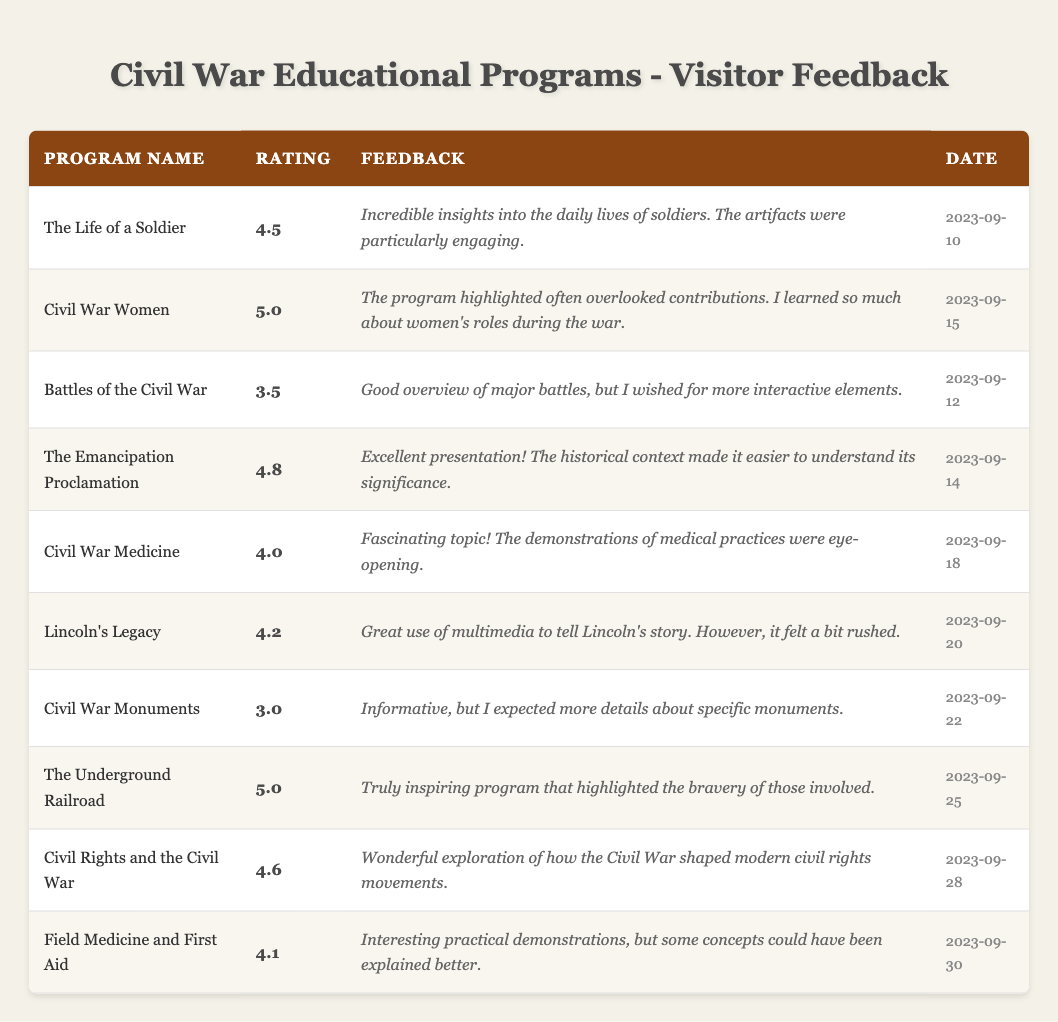What is the highest-rated program mentioned in the feedback? The program with the highest rating can be found by scanning the "Rating" column for the maximum value. "Civil War Women" and "The Underground Railroad" both have a rating of 5.0, which is the highest among all the programs.
Answer: Civil War Women, The Underground Railroad How many visitors rated the program "Civil Rights and the Civil War"? By looking at the "VisitorID" column for the program "Civil Rights and the Civil War," it can be observed that there is one entry with VisitorID 9. Thus, it received one rating.
Answer: 1 What is the average rating of all programs listed in the feedback? To calculate the average, sum all the ratings (4.5 + 5.0 + 3.5 + 4.8 + 4.0 + 4.2 + 3.0 + 5.0 + 4.6 + 4.1 = 44.7) and divide by the number of programs (10). The average is then 44.7 / 10 = 4.47.
Answer: 4.47 Did any program receive a rating below 4.0? By checking the "Rating" column, it is apparent that "Civil War Monuments" received a rating of 3.0, which is below 4.0. Thus, the answer is yes.
Answer: Yes Which program received feedback about the demonstrations being eye-opening? Scanning the "Feedback" column, the quote mentioning "demonstrations of medical practices were eye-opening" corresponds to the program "Civil War Medicine." Therefore, this program received that feedback.
Answer: Civil War Medicine What was the feedback for the program with the second highest rating? First, identify the two highest ratings: 5.0 and 4.8. The program with 4.8 is "The Emancipation Proclamation." The feedback states it had "Excellent presentation! The historical context made it easier to understand its significance."
Answer: Excellent presentation! The historical context made it easier to understand its significance How many programs had a rating of 4.5 or higher? Count the programs listed with ratings of 4.5 or greater by reviewing the "Rating" column. The qualifying ratings are 4.5, 5.0, 4.8, 4.0, 4.2, 5.0, 4.6, and 4.1, totaling 8 out of the 10 listed programs.
Answer: 8 Which program had feedback mentioning a desire for more interactive elements? By looking in the "Feedback" section, the statement about wishing for "more interactive elements" corresponds to the program "Battles of the Civil War." Therefore, this program had that specific feedback.
Answer: Battles of the Civil War What date was the program "Lincoln's Legacy" conducted? The date for "Lincoln's Legacy" can be found by matching the program name with its corresponding entry in the "Date" column, which shows it took place on September 20, 2023.
Answer: 2023-09-20 What feedback did visitors provide for the program "Field Medicine and First Aid"? The "Feedback" column for "Field Medicine and First Aid" states there were "Interesting practical demonstrations, but some concepts could have been explained better." This is the specific feedback provided.
Answer: Interesting practical demonstrations, but some concepts could have been explained better 